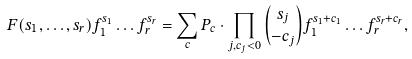<formula> <loc_0><loc_0><loc_500><loc_500>F ( s _ { 1 } , \dots , s _ { r } ) f _ { 1 } ^ { s _ { 1 } } \dots f _ { r } ^ { s _ { r } } = \sum _ { c } P _ { c } \cdot \prod _ { j , c _ { j } < 0 } { { s _ { j } } \choose { - c _ { j } } } f _ { 1 } ^ { s _ { 1 } + c _ { 1 } } \dots f _ { r } ^ { s _ { r } + c _ { r } } ,</formula> 